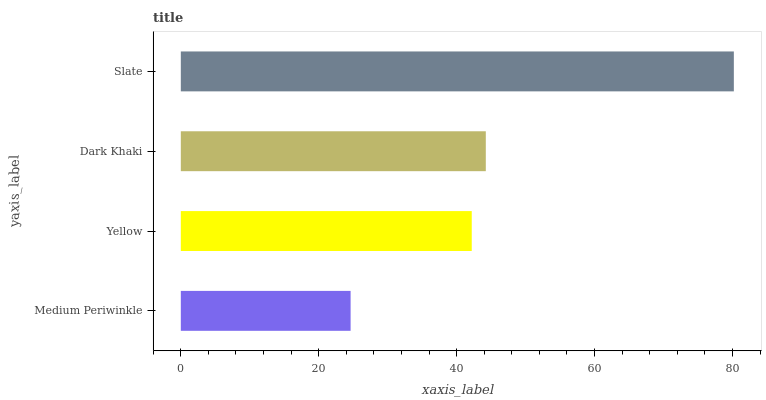Is Medium Periwinkle the minimum?
Answer yes or no. Yes. Is Slate the maximum?
Answer yes or no. Yes. Is Yellow the minimum?
Answer yes or no. No. Is Yellow the maximum?
Answer yes or no. No. Is Yellow greater than Medium Periwinkle?
Answer yes or no. Yes. Is Medium Periwinkle less than Yellow?
Answer yes or no. Yes. Is Medium Periwinkle greater than Yellow?
Answer yes or no. No. Is Yellow less than Medium Periwinkle?
Answer yes or no. No. Is Dark Khaki the high median?
Answer yes or no. Yes. Is Yellow the low median?
Answer yes or no. Yes. Is Medium Periwinkle the high median?
Answer yes or no. No. Is Dark Khaki the low median?
Answer yes or no. No. 